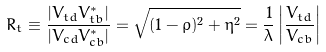Convert formula to latex. <formula><loc_0><loc_0><loc_500><loc_500>R _ { t } \equiv \frac { | V _ { t d } V ^ { * } _ { t b } | } { | V _ { c d } V ^ { * } _ { c b } | } = \sqrt { ( 1 - \bar { \varrho } ) ^ { 2 } + \bar { \eta } ^ { 2 } } = \frac { 1 } { \lambda } \left | \frac { V _ { t d } } { V _ { c b } } \right |</formula> 